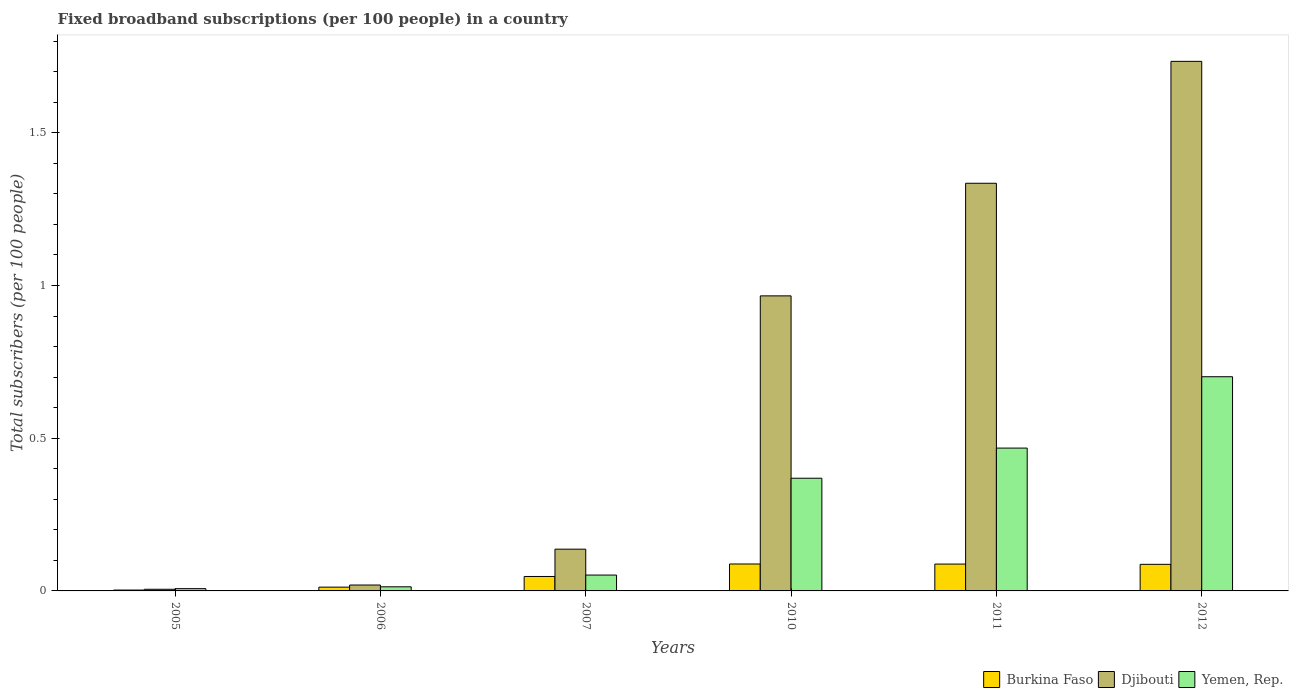What is the label of the 4th group of bars from the left?
Make the answer very short. 2010. What is the number of broadband subscriptions in Yemen, Rep. in 2005?
Your answer should be compact. 0.01. Across all years, what is the maximum number of broadband subscriptions in Yemen, Rep.?
Your answer should be compact. 0.7. Across all years, what is the minimum number of broadband subscriptions in Burkina Faso?
Ensure brevity in your answer.  0. In which year was the number of broadband subscriptions in Yemen, Rep. maximum?
Provide a succinct answer. 2012. What is the total number of broadband subscriptions in Yemen, Rep. in the graph?
Offer a very short reply. 1.61. What is the difference between the number of broadband subscriptions in Djibouti in 2006 and that in 2011?
Your response must be concise. -1.32. What is the difference between the number of broadband subscriptions in Djibouti in 2011 and the number of broadband subscriptions in Burkina Faso in 2007?
Make the answer very short. 1.29. What is the average number of broadband subscriptions in Djibouti per year?
Make the answer very short. 0.7. In the year 2012, what is the difference between the number of broadband subscriptions in Djibouti and number of broadband subscriptions in Yemen, Rep.?
Make the answer very short. 1.03. What is the ratio of the number of broadband subscriptions in Burkina Faso in 2005 to that in 2006?
Ensure brevity in your answer.  0.23. Is the number of broadband subscriptions in Yemen, Rep. in 2006 less than that in 2012?
Ensure brevity in your answer.  Yes. What is the difference between the highest and the second highest number of broadband subscriptions in Djibouti?
Provide a short and direct response. 0.4. What is the difference between the highest and the lowest number of broadband subscriptions in Burkina Faso?
Give a very brief answer. 0.09. In how many years, is the number of broadband subscriptions in Djibouti greater than the average number of broadband subscriptions in Djibouti taken over all years?
Provide a short and direct response. 3. What does the 3rd bar from the left in 2007 represents?
Make the answer very short. Yemen, Rep. What does the 1st bar from the right in 2005 represents?
Your answer should be compact. Yemen, Rep. Is it the case that in every year, the sum of the number of broadband subscriptions in Yemen, Rep. and number of broadband subscriptions in Djibouti is greater than the number of broadband subscriptions in Burkina Faso?
Make the answer very short. Yes. How many years are there in the graph?
Give a very brief answer. 6. Are the values on the major ticks of Y-axis written in scientific E-notation?
Provide a succinct answer. No. Does the graph contain any zero values?
Provide a succinct answer. No. Where does the legend appear in the graph?
Keep it short and to the point. Bottom right. How many legend labels are there?
Give a very brief answer. 3. How are the legend labels stacked?
Provide a short and direct response. Horizontal. What is the title of the graph?
Offer a terse response. Fixed broadband subscriptions (per 100 people) in a country. What is the label or title of the X-axis?
Ensure brevity in your answer.  Years. What is the label or title of the Y-axis?
Offer a very short reply. Total subscribers (per 100 people). What is the Total subscribers (per 100 people) of Burkina Faso in 2005?
Your answer should be very brief. 0. What is the Total subscribers (per 100 people) in Djibouti in 2005?
Offer a terse response. 0.01. What is the Total subscribers (per 100 people) of Yemen, Rep. in 2005?
Give a very brief answer. 0.01. What is the Total subscribers (per 100 people) of Burkina Faso in 2006?
Provide a short and direct response. 0.01. What is the Total subscribers (per 100 people) in Djibouti in 2006?
Make the answer very short. 0.02. What is the Total subscribers (per 100 people) in Yemen, Rep. in 2006?
Your response must be concise. 0.01. What is the Total subscribers (per 100 people) in Burkina Faso in 2007?
Offer a terse response. 0.05. What is the Total subscribers (per 100 people) of Djibouti in 2007?
Ensure brevity in your answer.  0.14. What is the Total subscribers (per 100 people) in Yemen, Rep. in 2007?
Your answer should be very brief. 0.05. What is the Total subscribers (per 100 people) in Burkina Faso in 2010?
Keep it short and to the point. 0.09. What is the Total subscribers (per 100 people) of Djibouti in 2010?
Make the answer very short. 0.97. What is the Total subscribers (per 100 people) in Yemen, Rep. in 2010?
Make the answer very short. 0.37. What is the Total subscribers (per 100 people) of Burkina Faso in 2011?
Your response must be concise. 0.09. What is the Total subscribers (per 100 people) of Djibouti in 2011?
Offer a very short reply. 1.33. What is the Total subscribers (per 100 people) of Yemen, Rep. in 2011?
Offer a terse response. 0.47. What is the Total subscribers (per 100 people) in Burkina Faso in 2012?
Ensure brevity in your answer.  0.09. What is the Total subscribers (per 100 people) in Djibouti in 2012?
Your response must be concise. 1.73. What is the Total subscribers (per 100 people) in Yemen, Rep. in 2012?
Your answer should be compact. 0.7. Across all years, what is the maximum Total subscribers (per 100 people) in Burkina Faso?
Give a very brief answer. 0.09. Across all years, what is the maximum Total subscribers (per 100 people) in Djibouti?
Your answer should be very brief. 1.73. Across all years, what is the maximum Total subscribers (per 100 people) of Yemen, Rep.?
Make the answer very short. 0.7. Across all years, what is the minimum Total subscribers (per 100 people) of Burkina Faso?
Your answer should be very brief. 0. Across all years, what is the minimum Total subscribers (per 100 people) in Djibouti?
Your answer should be compact. 0.01. Across all years, what is the minimum Total subscribers (per 100 people) of Yemen, Rep.?
Your response must be concise. 0.01. What is the total Total subscribers (per 100 people) in Burkina Faso in the graph?
Your response must be concise. 0.33. What is the total Total subscribers (per 100 people) in Djibouti in the graph?
Make the answer very short. 4.2. What is the total Total subscribers (per 100 people) in Yemen, Rep. in the graph?
Make the answer very short. 1.61. What is the difference between the Total subscribers (per 100 people) of Burkina Faso in 2005 and that in 2006?
Offer a terse response. -0.01. What is the difference between the Total subscribers (per 100 people) of Djibouti in 2005 and that in 2006?
Your answer should be compact. -0.01. What is the difference between the Total subscribers (per 100 people) of Yemen, Rep. in 2005 and that in 2006?
Provide a succinct answer. -0.01. What is the difference between the Total subscribers (per 100 people) in Burkina Faso in 2005 and that in 2007?
Your response must be concise. -0.04. What is the difference between the Total subscribers (per 100 people) of Djibouti in 2005 and that in 2007?
Offer a terse response. -0.13. What is the difference between the Total subscribers (per 100 people) in Yemen, Rep. in 2005 and that in 2007?
Your answer should be very brief. -0.04. What is the difference between the Total subscribers (per 100 people) of Burkina Faso in 2005 and that in 2010?
Provide a succinct answer. -0.09. What is the difference between the Total subscribers (per 100 people) of Djibouti in 2005 and that in 2010?
Your answer should be very brief. -0.96. What is the difference between the Total subscribers (per 100 people) in Yemen, Rep. in 2005 and that in 2010?
Make the answer very short. -0.36. What is the difference between the Total subscribers (per 100 people) in Burkina Faso in 2005 and that in 2011?
Provide a short and direct response. -0.09. What is the difference between the Total subscribers (per 100 people) of Djibouti in 2005 and that in 2011?
Make the answer very short. -1.33. What is the difference between the Total subscribers (per 100 people) of Yemen, Rep. in 2005 and that in 2011?
Make the answer very short. -0.46. What is the difference between the Total subscribers (per 100 people) in Burkina Faso in 2005 and that in 2012?
Offer a very short reply. -0.08. What is the difference between the Total subscribers (per 100 people) of Djibouti in 2005 and that in 2012?
Ensure brevity in your answer.  -1.73. What is the difference between the Total subscribers (per 100 people) in Yemen, Rep. in 2005 and that in 2012?
Offer a terse response. -0.69. What is the difference between the Total subscribers (per 100 people) of Burkina Faso in 2006 and that in 2007?
Ensure brevity in your answer.  -0.03. What is the difference between the Total subscribers (per 100 people) of Djibouti in 2006 and that in 2007?
Make the answer very short. -0.12. What is the difference between the Total subscribers (per 100 people) in Yemen, Rep. in 2006 and that in 2007?
Your answer should be compact. -0.04. What is the difference between the Total subscribers (per 100 people) in Burkina Faso in 2006 and that in 2010?
Give a very brief answer. -0.08. What is the difference between the Total subscribers (per 100 people) in Djibouti in 2006 and that in 2010?
Make the answer very short. -0.95. What is the difference between the Total subscribers (per 100 people) of Yemen, Rep. in 2006 and that in 2010?
Offer a very short reply. -0.36. What is the difference between the Total subscribers (per 100 people) in Burkina Faso in 2006 and that in 2011?
Make the answer very short. -0.08. What is the difference between the Total subscribers (per 100 people) of Djibouti in 2006 and that in 2011?
Your answer should be very brief. -1.32. What is the difference between the Total subscribers (per 100 people) of Yemen, Rep. in 2006 and that in 2011?
Offer a very short reply. -0.45. What is the difference between the Total subscribers (per 100 people) in Burkina Faso in 2006 and that in 2012?
Your response must be concise. -0.07. What is the difference between the Total subscribers (per 100 people) in Djibouti in 2006 and that in 2012?
Your answer should be very brief. -1.71. What is the difference between the Total subscribers (per 100 people) in Yemen, Rep. in 2006 and that in 2012?
Your answer should be very brief. -0.69. What is the difference between the Total subscribers (per 100 people) of Burkina Faso in 2007 and that in 2010?
Offer a terse response. -0.04. What is the difference between the Total subscribers (per 100 people) in Djibouti in 2007 and that in 2010?
Your response must be concise. -0.83. What is the difference between the Total subscribers (per 100 people) in Yemen, Rep. in 2007 and that in 2010?
Your response must be concise. -0.32. What is the difference between the Total subscribers (per 100 people) in Burkina Faso in 2007 and that in 2011?
Make the answer very short. -0.04. What is the difference between the Total subscribers (per 100 people) in Djibouti in 2007 and that in 2011?
Provide a succinct answer. -1.2. What is the difference between the Total subscribers (per 100 people) in Yemen, Rep. in 2007 and that in 2011?
Keep it short and to the point. -0.42. What is the difference between the Total subscribers (per 100 people) in Burkina Faso in 2007 and that in 2012?
Offer a very short reply. -0.04. What is the difference between the Total subscribers (per 100 people) in Djibouti in 2007 and that in 2012?
Offer a very short reply. -1.6. What is the difference between the Total subscribers (per 100 people) in Yemen, Rep. in 2007 and that in 2012?
Offer a very short reply. -0.65. What is the difference between the Total subscribers (per 100 people) in Djibouti in 2010 and that in 2011?
Provide a succinct answer. -0.37. What is the difference between the Total subscribers (per 100 people) in Yemen, Rep. in 2010 and that in 2011?
Keep it short and to the point. -0.1. What is the difference between the Total subscribers (per 100 people) in Burkina Faso in 2010 and that in 2012?
Offer a terse response. 0. What is the difference between the Total subscribers (per 100 people) of Djibouti in 2010 and that in 2012?
Give a very brief answer. -0.77. What is the difference between the Total subscribers (per 100 people) in Yemen, Rep. in 2010 and that in 2012?
Keep it short and to the point. -0.33. What is the difference between the Total subscribers (per 100 people) of Burkina Faso in 2011 and that in 2012?
Your response must be concise. 0. What is the difference between the Total subscribers (per 100 people) of Djibouti in 2011 and that in 2012?
Keep it short and to the point. -0.4. What is the difference between the Total subscribers (per 100 people) in Yemen, Rep. in 2011 and that in 2012?
Make the answer very short. -0.23. What is the difference between the Total subscribers (per 100 people) of Burkina Faso in 2005 and the Total subscribers (per 100 people) of Djibouti in 2006?
Make the answer very short. -0.02. What is the difference between the Total subscribers (per 100 people) of Burkina Faso in 2005 and the Total subscribers (per 100 people) of Yemen, Rep. in 2006?
Offer a very short reply. -0.01. What is the difference between the Total subscribers (per 100 people) of Djibouti in 2005 and the Total subscribers (per 100 people) of Yemen, Rep. in 2006?
Offer a terse response. -0.01. What is the difference between the Total subscribers (per 100 people) of Burkina Faso in 2005 and the Total subscribers (per 100 people) of Djibouti in 2007?
Offer a very short reply. -0.13. What is the difference between the Total subscribers (per 100 people) of Burkina Faso in 2005 and the Total subscribers (per 100 people) of Yemen, Rep. in 2007?
Offer a terse response. -0.05. What is the difference between the Total subscribers (per 100 people) in Djibouti in 2005 and the Total subscribers (per 100 people) in Yemen, Rep. in 2007?
Provide a short and direct response. -0.05. What is the difference between the Total subscribers (per 100 people) in Burkina Faso in 2005 and the Total subscribers (per 100 people) in Djibouti in 2010?
Offer a very short reply. -0.96. What is the difference between the Total subscribers (per 100 people) of Burkina Faso in 2005 and the Total subscribers (per 100 people) of Yemen, Rep. in 2010?
Offer a terse response. -0.37. What is the difference between the Total subscribers (per 100 people) in Djibouti in 2005 and the Total subscribers (per 100 people) in Yemen, Rep. in 2010?
Offer a very short reply. -0.36. What is the difference between the Total subscribers (per 100 people) of Burkina Faso in 2005 and the Total subscribers (per 100 people) of Djibouti in 2011?
Offer a terse response. -1.33. What is the difference between the Total subscribers (per 100 people) in Burkina Faso in 2005 and the Total subscribers (per 100 people) in Yemen, Rep. in 2011?
Give a very brief answer. -0.46. What is the difference between the Total subscribers (per 100 people) in Djibouti in 2005 and the Total subscribers (per 100 people) in Yemen, Rep. in 2011?
Offer a very short reply. -0.46. What is the difference between the Total subscribers (per 100 people) of Burkina Faso in 2005 and the Total subscribers (per 100 people) of Djibouti in 2012?
Your answer should be very brief. -1.73. What is the difference between the Total subscribers (per 100 people) in Burkina Faso in 2005 and the Total subscribers (per 100 people) in Yemen, Rep. in 2012?
Provide a short and direct response. -0.7. What is the difference between the Total subscribers (per 100 people) of Djibouti in 2005 and the Total subscribers (per 100 people) of Yemen, Rep. in 2012?
Make the answer very short. -0.7. What is the difference between the Total subscribers (per 100 people) of Burkina Faso in 2006 and the Total subscribers (per 100 people) of Djibouti in 2007?
Give a very brief answer. -0.12. What is the difference between the Total subscribers (per 100 people) of Burkina Faso in 2006 and the Total subscribers (per 100 people) of Yemen, Rep. in 2007?
Offer a very short reply. -0.04. What is the difference between the Total subscribers (per 100 people) of Djibouti in 2006 and the Total subscribers (per 100 people) of Yemen, Rep. in 2007?
Give a very brief answer. -0.03. What is the difference between the Total subscribers (per 100 people) in Burkina Faso in 2006 and the Total subscribers (per 100 people) in Djibouti in 2010?
Offer a terse response. -0.95. What is the difference between the Total subscribers (per 100 people) of Burkina Faso in 2006 and the Total subscribers (per 100 people) of Yemen, Rep. in 2010?
Offer a terse response. -0.36. What is the difference between the Total subscribers (per 100 people) of Djibouti in 2006 and the Total subscribers (per 100 people) of Yemen, Rep. in 2010?
Provide a succinct answer. -0.35. What is the difference between the Total subscribers (per 100 people) in Burkina Faso in 2006 and the Total subscribers (per 100 people) in Djibouti in 2011?
Give a very brief answer. -1.32. What is the difference between the Total subscribers (per 100 people) of Burkina Faso in 2006 and the Total subscribers (per 100 people) of Yemen, Rep. in 2011?
Make the answer very short. -0.46. What is the difference between the Total subscribers (per 100 people) of Djibouti in 2006 and the Total subscribers (per 100 people) of Yemen, Rep. in 2011?
Ensure brevity in your answer.  -0.45. What is the difference between the Total subscribers (per 100 people) of Burkina Faso in 2006 and the Total subscribers (per 100 people) of Djibouti in 2012?
Make the answer very short. -1.72. What is the difference between the Total subscribers (per 100 people) in Burkina Faso in 2006 and the Total subscribers (per 100 people) in Yemen, Rep. in 2012?
Your response must be concise. -0.69. What is the difference between the Total subscribers (per 100 people) in Djibouti in 2006 and the Total subscribers (per 100 people) in Yemen, Rep. in 2012?
Offer a very short reply. -0.68. What is the difference between the Total subscribers (per 100 people) of Burkina Faso in 2007 and the Total subscribers (per 100 people) of Djibouti in 2010?
Your answer should be very brief. -0.92. What is the difference between the Total subscribers (per 100 people) of Burkina Faso in 2007 and the Total subscribers (per 100 people) of Yemen, Rep. in 2010?
Ensure brevity in your answer.  -0.32. What is the difference between the Total subscribers (per 100 people) in Djibouti in 2007 and the Total subscribers (per 100 people) in Yemen, Rep. in 2010?
Your response must be concise. -0.23. What is the difference between the Total subscribers (per 100 people) of Burkina Faso in 2007 and the Total subscribers (per 100 people) of Djibouti in 2011?
Keep it short and to the point. -1.29. What is the difference between the Total subscribers (per 100 people) of Burkina Faso in 2007 and the Total subscribers (per 100 people) of Yemen, Rep. in 2011?
Keep it short and to the point. -0.42. What is the difference between the Total subscribers (per 100 people) of Djibouti in 2007 and the Total subscribers (per 100 people) of Yemen, Rep. in 2011?
Provide a short and direct response. -0.33. What is the difference between the Total subscribers (per 100 people) in Burkina Faso in 2007 and the Total subscribers (per 100 people) in Djibouti in 2012?
Make the answer very short. -1.69. What is the difference between the Total subscribers (per 100 people) in Burkina Faso in 2007 and the Total subscribers (per 100 people) in Yemen, Rep. in 2012?
Offer a very short reply. -0.65. What is the difference between the Total subscribers (per 100 people) of Djibouti in 2007 and the Total subscribers (per 100 people) of Yemen, Rep. in 2012?
Ensure brevity in your answer.  -0.56. What is the difference between the Total subscribers (per 100 people) of Burkina Faso in 2010 and the Total subscribers (per 100 people) of Djibouti in 2011?
Give a very brief answer. -1.25. What is the difference between the Total subscribers (per 100 people) in Burkina Faso in 2010 and the Total subscribers (per 100 people) in Yemen, Rep. in 2011?
Provide a succinct answer. -0.38. What is the difference between the Total subscribers (per 100 people) in Djibouti in 2010 and the Total subscribers (per 100 people) in Yemen, Rep. in 2011?
Ensure brevity in your answer.  0.5. What is the difference between the Total subscribers (per 100 people) of Burkina Faso in 2010 and the Total subscribers (per 100 people) of Djibouti in 2012?
Keep it short and to the point. -1.65. What is the difference between the Total subscribers (per 100 people) in Burkina Faso in 2010 and the Total subscribers (per 100 people) in Yemen, Rep. in 2012?
Your answer should be compact. -0.61. What is the difference between the Total subscribers (per 100 people) of Djibouti in 2010 and the Total subscribers (per 100 people) of Yemen, Rep. in 2012?
Make the answer very short. 0.26. What is the difference between the Total subscribers (per 100 people) in Burkina Faso in 2011 and the Total subscribers (per 100 people) in Djibouti in 2012?
Offer a terse response. -1.65. What is the difference between the Total subscribers (per 100 people) of Burkina Faso in 2011 and the Total subscribers (per 100 people) of Yemen, Rep. in 2012?
Your answer should be very brief. -0.61. What is the difference between the Total subscribers (per 100 people) in Djibouti in 2011 and the Total subscribers (per 100 people) in Yemen, Rep. in 2012?
Your answer should be very brief. 0.63. What is the average Total subscribers (per 100 people) of Burkina Faso per year?
Offer a terse response. 0.05. What is the average Total subscribers (per 100 people) in Djibouti per year?
Your response must be concise. 0.7. What is the average Total subscribers (per 100 people) in Yemen, Rep. per year?
Provide a succinct answer. 0.27. In the year 2005, what is the difference between the Total subscribers (per 100 people) in Burkina Faso and Total subscribers (per 100 people) in Djibouti?
Provide a succinct answer. -0. In the year 2005, what is the difference between the Total subscribers (per 100 people) in Burkina Faso and Total subscribers (per 100 people) in Yemen, Rep.?
Ensure brevity in your answer.  -0. In the year 2005, what is the difference between the Total subscribers (per 100 people) of Djibouti and Total subscribers (per 100 people) of Yemen, Rep.?
Offer a very short reply. -0. In the year 2006, what is the difference between the Total subscribers (per 100 people) in Burkina Faso and Total subscribers (per 100 people) in Djibouti?
Your response must be concise. -0.01. In the year 2006, what is the difference between the Total subscribers (per 100 people) in Burkina Faso and Total subscribers (per 100 people) in Yemen, Rep.?
Give a very brief answer. -0. In the year 2006, what is the difference between the Total subscribers (per 100 people) of Djibouti and Total subscribers (per 100 people) of Yemen, Rep.?
Offer a terse response. 0.01. In the year 2007, what is the difference between the Total subscribers (per 100 people) of Burkina Faso and Total subscribers (per 100 people) of Djibouti?
Keep it short and to the point. -0.09. In the year 2007, what is the difference between the Total subscribers (per 100 people) in Burkina Faso and Total subscribers (per 100 people) in Yemen, Rep.?
Offer a very short reply. -0. In the year 2007, what is the difference between the Total subscribers (per 100 people) in Djibouti and Total subscribers (per 100 people) in Yemen, Rep.?
Offer a terse response. 0.08. In the year 2010, what is the difference between the Total subscribers (per 100 people) in Burkina Faso and Total subscribers (per 100 people) in Djibouti?
Offer a very short reply. -0.88. In the year 2010, what is the difference between the Total subscribers (per 100 people) in Burkina Faso and Total subscribers (per 100 people) in Yemen, Rep.?
Offer a terse response. -0.28. In the year 2010, what is the difference between the Total subscribers (per 100 people) of Djibouti and Total subscribers (per 100 people) of Yemen, Rep.?
Give a very brief answer. 0.6. In the year 2011, what is the difference between the Total subscribers (per 100 people) in Burkina Faso and Total subscribers (per 100 people) in Djibouti?
Your answer should be compact. -1.25. In the year 2011, what is the difference between the Total subscribers (per 100 people) in Burkina Faso and Total subscribers (per 100 people) in Yemen, Rep.?
Offer a very short reply. -0.38. In the year 2011, what is the difference between the Total subscribers (per 100 people) in Djibouti and Total subscribers (per 100 people) in Yemen, Rep.?
Your response must be concise. 0.87. In the year 2012, what is the difference between the Total subscribers (per 100 people) in Burkina Faso and Total subscribers (per 100 people) in Djibouti?
Ensure brevity in your answer.  -1.65. In the year 2012, what is the difference between the Total subscribers (per 100 people) in Burkina Faso and Total subscribers (per 100 people) in Yemen, Rep.?
Keep it short and to the point. -0.61. In the year 2012, what is the difference between the Total subscribers (per 100 people) in Djibouti and Total subscribers (per 100 people) in Yemen, Rep.?
Provide a short and direct response. 1.03. What is the ratio of the Total subscribers (per 100 people) of Burkina Faso in 2005 to that in 2006?
Your response must be concise. 0.23. What is the ratio of the Total subscribers (per 100 people) in Djibouti in 2005 to that in 2006?
Your answer should be very brief. 0.28. What is the ratio of the Total subscribers (per 100 people) in Yemen, Rep. in 2005 to that in 2006?
Ensure brevity in your answer.  0.55. What is the ratio of the Total subscribers (per 100 people) of Burkina Faso in 2005 to that in 2007?
Offer a very short reply. 0.06. What is the ratio of the Total subscribers (per 100 people) in Djibouti in 2005 to that in 2007?
Give a very brief answer. 0.04. What is the ratio of the Total subscribers (per 100 people) in Yemen, Rep. in 2005 to that in 2007?
Your answer should be very brief. 0.14. What is the ratio of the Total subscribers (per 100 people) of Burkina Faso in 2005 to that in 2010?
Keep it short and to the point. 0.03. What is the ratio of the Total subscribers (per 100 people) in Djibouti in 2005 to that in 2010?
Keep it short and to the point. 0.01. What is the ratio of the Total subscribers (per 100 people) of Yemen, Rep. in 2005 to that in 2010?
Provide a short and direct response. 0.02. What is the ratio of the Total subscribers (per 100 people) of Burkina Faso in 2005 to that in 2011?
Give a very brief answer. 0.03. What is the ratio of the Total subscribers (per 100 people) of Djibouti in 2005 to that in 2011?
Your answer should be very brief. 0. What is the ratio of the Total subscribers (per 100 people) of Yemen, Rep. in 2005 to that in 2011?
Offer a terse response. 0.02. What is the ratio of the Total subscribers (per 100 people) in Burkina Faso in 2005 to that in 2012?
Offer a terse response. 0.03. What is the ratio of the Total subscribers (per 100 people) of Djibouti in 2005 to that in 2012?
Your answer should be very brief. 0. What is the ratio of the Total subscribers (per 100 people) in Yemen, Rep. in 2005 to that in 2012?
Your response must be concise. 0.01. What is the ratio of the Total subscribers (per 100 people) in Burkina Faso in 2006 to that in 2007?
Offer a terse response. 0.26. What is the ratio of the Total subscribers (per 100 people) in Djibouti in 2006 to that in 2007?
Make the answer very short. 0.14. What is the ratio of the Total subscribers (per 100 people) in Yemen, Rep. in 2006 to that in 2007?
Your answer should be compact. 0.26. What is the ratio of the Total subscribers (per 100 people) in Burkina Faso in 2006 to that in 2010?
Offer a terse response. 0.14. What is the ratio of the Total subscribers (per 100 people) of Yemen, Rep. in 2006 to that in 2010?
Your answer should be compact. 0.04. What is the ratio of the Total subscribers (per 100 people) in Burkina Faso in 2006 to that in 2011?
Provide a short and direct response. 0.14. What is the ratio of the Total subscribers (per 100 people) in Djibouti in 2006 to that in 2011?
Ensure brevity in your answer.  0.01. What is the ratio of the Total subscribers (per 100 people) of Yemen, Rep. in 2006 to that in 2011?
Give a very brief answer. 0.03. What is the ratio of the Total subscribers (per 100 people) of Burkina Faso in 2006 to that in 2012?
Your answer should be very brief. 0.14. What is the ratio of the Total subscribers (per 100 people) of Djibouti in 2006 to that in 2012?
Provide a succinct answer. 0.01. What is the ratio of the Total subscribers (per 100 people) in Yemen, Rep. in 2006 to that in 2012?
Your answer should be very brief. 0.02. What is the ratio of the Total subscribers (per 100 people) in Burkina Faso in 2007 to that in 2010?
Your answer should be very brief. 0.54. What is the ratio of the Total subscribers (per 100 people) in Djibouti in 2007 to that in 2010?
Your answer should be compact. 0.14. What is the ratio of the Total subscribers (per 100 people) of Yemen, Rep. in 2007 to that in 2010?
Provide a succinct answer. 0.14. What is the ratio of the Total subscribers (per 100 people) in Burkina Faso in 2007 to that in 2011?
Your answer should be compact. 0.54. What is the ratio of the Total subscribers (per 100 people) in Djibouti in 2007 to that in 2011?
Provide a succinct answer. 0.1. What is the ratio of the Total subscribers (per 100 people) in Yemen, Rep. in 2007 to that in 2011?
Keep it short and to the point. 0.11. What is the ratio of the Total subscribers (per 100 people) of Burkina Faso in 2007 to that in 2012?
Give a very brief answer. 0.54. What is the ratio of the Total subscribers (per 100 people) of Djibouti in 2007 to that in 2012?
Make the answer very short. 0.08. What is the ratio of the Total subscribers (per 100 people) of Yemen, Rep. in 2007 to that in 2012?
Your answer should be very brief. 0.07. What is the ratio of the Total subscribers (per 100 people) in Djibouti in 2010 to that in 2011?
Provide a succinct answer. 0.72. What is the ratio of the Total subscribers (per 100 people) in Yemen, Rep. in 2010 to that in 2011?
Your answer should be very brief. 0.79. What is the ratio of the Total subscribers (per 100 people) of Burkina Faso in 2010 to that in 2012?
Your answer should be compact. 1.01. What is the ratio of the Total subscribers (per 100 people) of Djibouti in 2010 to that in 2012?
Your answer should be very brief. 0.56. What is the ratio of the Total subscribers (per 100 people) in Yemen, Rep. in 2010 to that in 2012?
Provide a succinct answer. 0.53. What is the ratio of the Total subscribers (per 100 people) in Burkina Faso in 2011 to that in 2012?
Make the answer very short. 1.01. What is the ratio of the Total subscribers (per 100 people) of Djibouti in 2011 to that in 2012?
Make the answer very short. 0.77. What is the ratio of the Total subscribers (per 100 people) in Yemen, Rep. in 2011 to that in 2012?
Give a very brief answer. 0.67. What is the difference between the highest and the second highest Total subscribers (per 100 people) in Burkina Faso?
Your answer should be compact. 0. What is the difference between the highest and the second highest Total subscribers (per 100 people) in Djibouti?
Give a very brief answer. 0.4. What is the difference between the highest and the second highest Total subscribers (per 100 people) in Yemen, Rep.?
Give a very brief answer. 0.23. What is the difference between the highest and the lowest Total subscribers (per 100 people) in Burkina Faso?
Ensure brevity in your answer.  0.09. What is the difference between the highest and the lowest Total subscribers (per 100 people) of Djibouti?
Give a very brief answer. 1.73. What is the difference between the highest and the lowest Total subscribers (per 100 people) in Yemen, Rep.?
Ensure brevity in your answer.  0.69. 